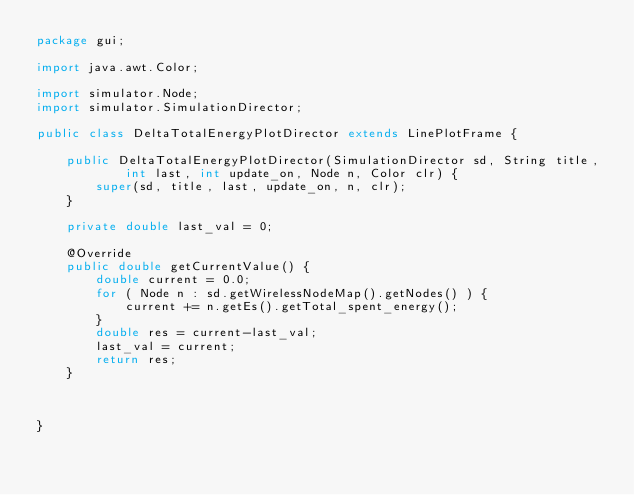Convert code to text. <code><loc_0><loc_0><loc_500><loc_500><_Java_>package gui;

import java.awt.Color;

import simulator.Node;
import simulator.SimulationDirector;

public class DeltaTotalEnergyPlotDirector extends LinePlotFrame {

	public DeltaTotalEnergyPlotDirector(SimulationDirector sd, String title,
			int last, int update_on, Node n, Color clr) {
		super(sd, title, last, update_on, n, clr);
	}

	private double last_val = 0;

	@Override
	public double getCurrentValue() {
		double current = 0.0;
		for ( Node n : sd.getWirelessNodeMap().getNodes() ) {
			current += n.getEs().getTotal_spent_energy();
		}
		double res = current-last_val;
		last_val = current;
		return res;
	}

	

}
</code> 